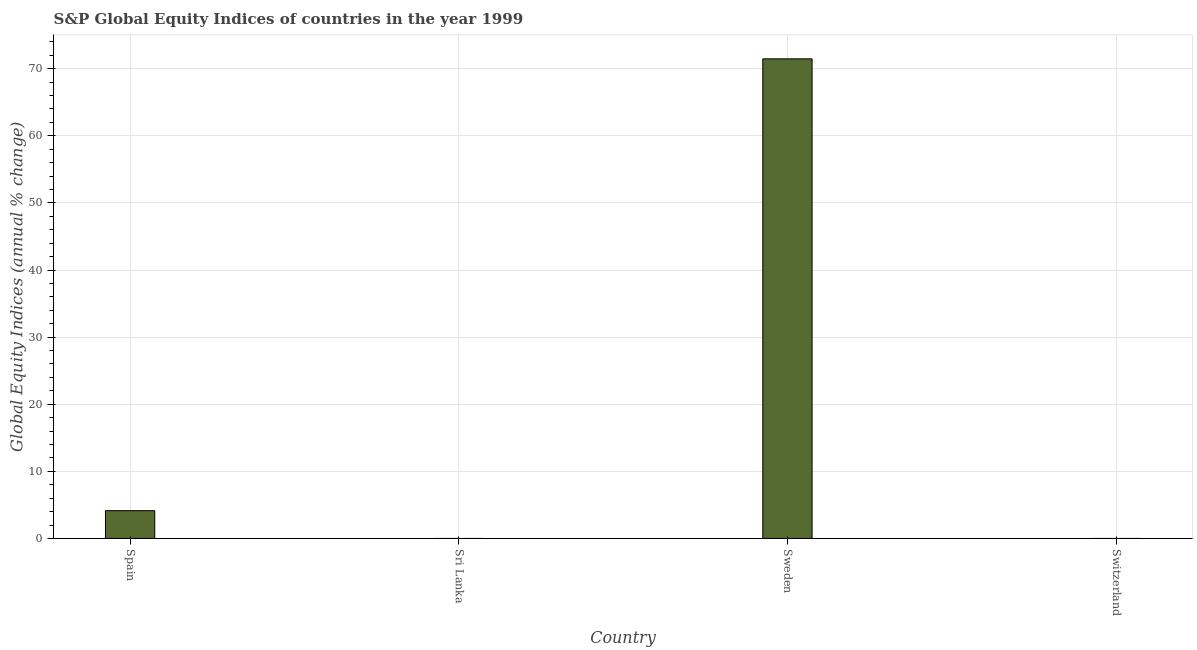Does the graph contain grids?
Offer a very short reply. Yes. What is the title of the graph?
Ensure brevity in your answer.  S&P Global Equity Indices of countries in the year 1999. What is the label or title of the Y-axis?
Your response must be concise. Global Equity Indices (annual % change). What is the s&p global equity indices in Sweden?
Provide a short and direct response. 71.47. Across all countries, what is the maximum s&p global equity indices?
Your answer should be compact. 71.47. In which country was the s&p global equity indices maximum?
Your answer should be compact. Sweden. What is the sum of the s&p global equity indices?
Ensure brevity in your answer.  75.61. What is the difference between the s&p global equity indices in Spain and Sweden?
Your answer should be very brief. -67.33. What is the average s&p global equity indices per country?
Give a very brief answer. 18.9. What is the median s&p global equity indices?
Offer a very short reply. 2.07. What is the ratio of the s&p global equity indices in Spain to that in Sweden?
Ensure brevity in your answer.  0.06. What is the difference between the highest and the lowest s&p global equity indices?
Offer a terse response. 71.47. How many bars are there?
Provide a succinct answer. 2. What is the difference between two consecutive major ticks on the Y-axis?
Your answer should be very brief. 10. Are the values on the major ticks of Y-axis written in scientific E-notation?
Your response must be concise. No. What is the Global Equity Indices (annual % change) of Spain?
Offer a very short reply. 4.14. What is the Global Equity Indices (annual % change) of Sweden?
Keep it short and to the point. 71.47. What is the Global Equity Indices (annual % change) of Switzerland?
Your answer should be compact. 0. What is the difference between the Global Equity Indices (annual % change) in Spain and Sweden?
Your answer should be very brief. -67.33. What is the ratio of the Global Equity Indices (annual % change) in Spain to that in Sweden?
Your response must be concise. 0.06. 